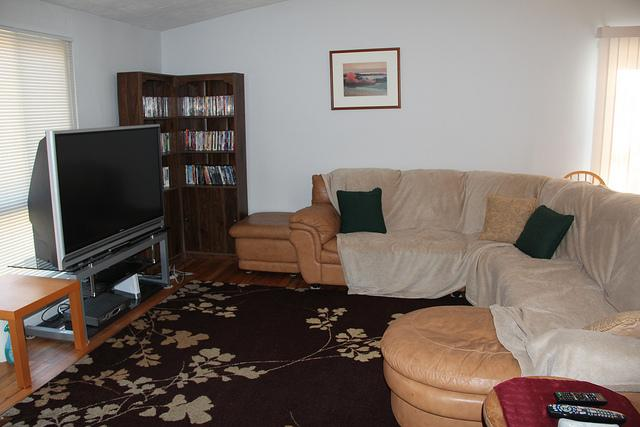How many portraits are hung on the white wall? one 